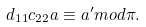Convert formula to latex. <formula><loc_0><loc_0><loc_500><loc_500>d _ { 1 1 } c _ { 2 2 } a \equiv a ^ { \prime } m o d \pi .</formula> 